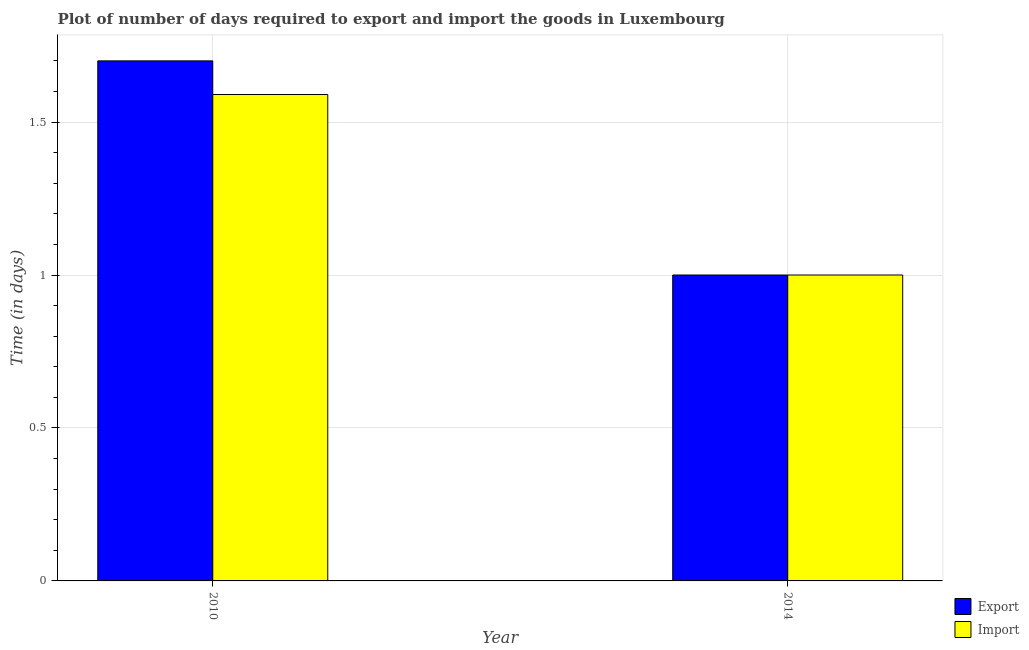Are the number of bars per tick equal to the number of legend labels?
Your response must be concise. Yes. Are the number of bars on each tick of the X-axis equal?
Provide a short and direct response. Yes. How many bars are there on the 2nd tick from the left?
Keep it short and to the point. 2. How many bars are there on the 1st tick from the right?
Make the answer very short. 2. What is the label of the 1st group of bars from the left?
Give a very brief answer. 2010. In how many cases, is the number of bars for a given year not equal to the number of legend labels?
Provide a short and direct response. 0. Across all years, what is the minimum time required to export?
Offer a very short reply. 1. What is the difference between the time required to export in 2014 and the time required to import in 2010?
Ensure brevity in your answer.  -0.7. What is the average time required to import per year?
Give a very brief answer. 1.29. What is the ratio of the time required to import in 2010 to that in 2014?
Offer a terse response. 1.59. In how many years, is the time required to import greater than the average time required to import taken over all years?
Provide a short and direct response. 1. What does the 1st bar from the left in 2014 represents?
Provide a short and direct response. Export. What does the 1st bar from the right in 2014 represents?
Offer a terse response. Import. Are all the bars in the graph horizontal?
Give a very brief answer. No. What is the difference between two consecutive major ticks on the Y-axis?
Give a very brief answer. 0.5. How are the legend labels stacked?
Your answer should be very brief. Vertical. What is the title of the graph?
Keep it short and to the point. Plot of number of days required to export and import the goods in Luxembourg. What is the label or title of the X-axis?
Provide a short and direct response. Year. What is the label or title of the Y-axis?
Keep it short and to the point. Time (in days). What is the Time (in days) of Export in 2010?
Your answer should be compact. 1.7. What is the Time (in days) of Import in 2010?
Your answer should be very brief. 1.59. What is the Time (in days) in Export in 2014?
Provide a succinct answer. 1. Across all years, what is the maximum Time (in days) in Export?
Give a very brief answer. 1.7. Across all years, what is the maximum Time (in days) of Import?
Provide a short and direct response. 1.59. What is the total Time (in days) of Import in the graph?
Make the answer very short. 2.59. What is the difference between the Time (in days) in Import in 2010 and that in 2014?
Give a very brief answer. 0.59. What is the average Time (in days) of Export per year?
Provide a short and direct response. 1.35. What is the average Time (in days) in Import per year?
Make the answer very short. 1.29. In the year 2010, what is the difference between the Time (in days) in Export and Time (in days) in Import?
Your answer should be compact. 0.11. What is the ratio of the Time (in days) of Import in 2010 to that in 2014?
Your answer should be compact. 1.59. What is the difference between the highest and the second highest Time (in days) in Import?
Keep it short and to the point. 0.59. What is the difference between the highest and the lowest Time (in days) of Import?
Offer a terse response. 0.59. 